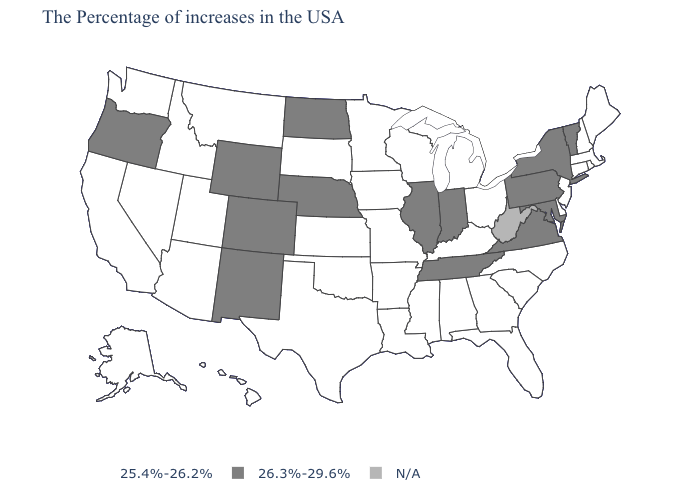Among the states that border South Carolina , which have the lowest value?
Concise answer only. North Carolina, Georgia. Among the states that border North Carolina , which have the lowest value?
Concise answer only. South Carolina, Georgia. What is the value of Iowa?
Short answer required. 25.4%-26.2%. Name the states that have a value in the range 26.3%-29.6%?
Keep it brief. Vermont, New York, Maryland, Pennsylvania, Virginia, Indiana, Tennessee, Illinois, Nebraska, North Dakota, Wyoming, Colorado, New Mexico, Oregon. What is the highest value in the USA?
Give a very brief answer. 26.3%-29.6%. Which states have the lowest value in the USA?
Keep it brief. Maine, Massachusetts, Rhode Island, New Hampshire, Connecticut, New Jersey, Delaware, North Carolina, South Carolina, Ohio, Florida, Georgia, Michigan, Kentucky, Alabama, Wisconsin, Mississippi, Louisiana, Missouri, Arkansas, Minnesota, Iowa, Kansas, Oklahoma, Texas, South Dakota, Utah, Montana, Arizona, Idaho, Nevada, California, Washington, Alaska, Hawaii. Which states have the lowest value in the USA?
Keep it brief. Maine, Massachusetts, Rhode Island, New Hampshire, Connecticut, New Jersey, Delaware, North Carolina, South Carolina, Ohio, Florida, Georgia, Michigan, Kentucky, Alabama, Wisconsin, Mississippi, Louisiana, Missouri, Arkansas, Minnesota, Iowa, Kansas, Oklahoma, Texas, South Dakota, Utah, Montana, Arizona, Idaho, Nevada, California, Washington, Alaska, Hawaii. What is the lowest value in the USA?
Write a very short answer. 25.4%-26.2%. Name the states that have a value in the range 25.4%-26.2%?
Short answer required. Maine, Massachusetts, Rhode Island, New Hampshire, Connecticut, New Jersey, Delaware, North Carolina, South Carolina, Ohio, Florida, Georgia, Michigan, Kentucky, Alabama, Wisconsin, Mississippi, Louisiana, Missouri, Arkansas, Minnesota, Iowa, Kansas, Oklahoma, Texas, South Dakota, Utah, Montana, Arizona, Idaho, Nevada, California, Washington, Alaska, Hawaii. What is the highest value in the USA?
Give a very brief answer. 26.3%-29.6%. Name the states that have a value in the range 26.3%-29.6%?
Keep it brief. Vermont, New York, Maryland, Pennsylvania, Virginia, Indiana, Tennessee, Illinois, Nebraska, North Dakota, Wyoming, Colorado, New Mexico, Oregon. Name the states that have a value in the range N/A?
Answer briefly. West Virginia. Among the states that border Indiana , which have the highest value?
Answer briefly. Illinois. 